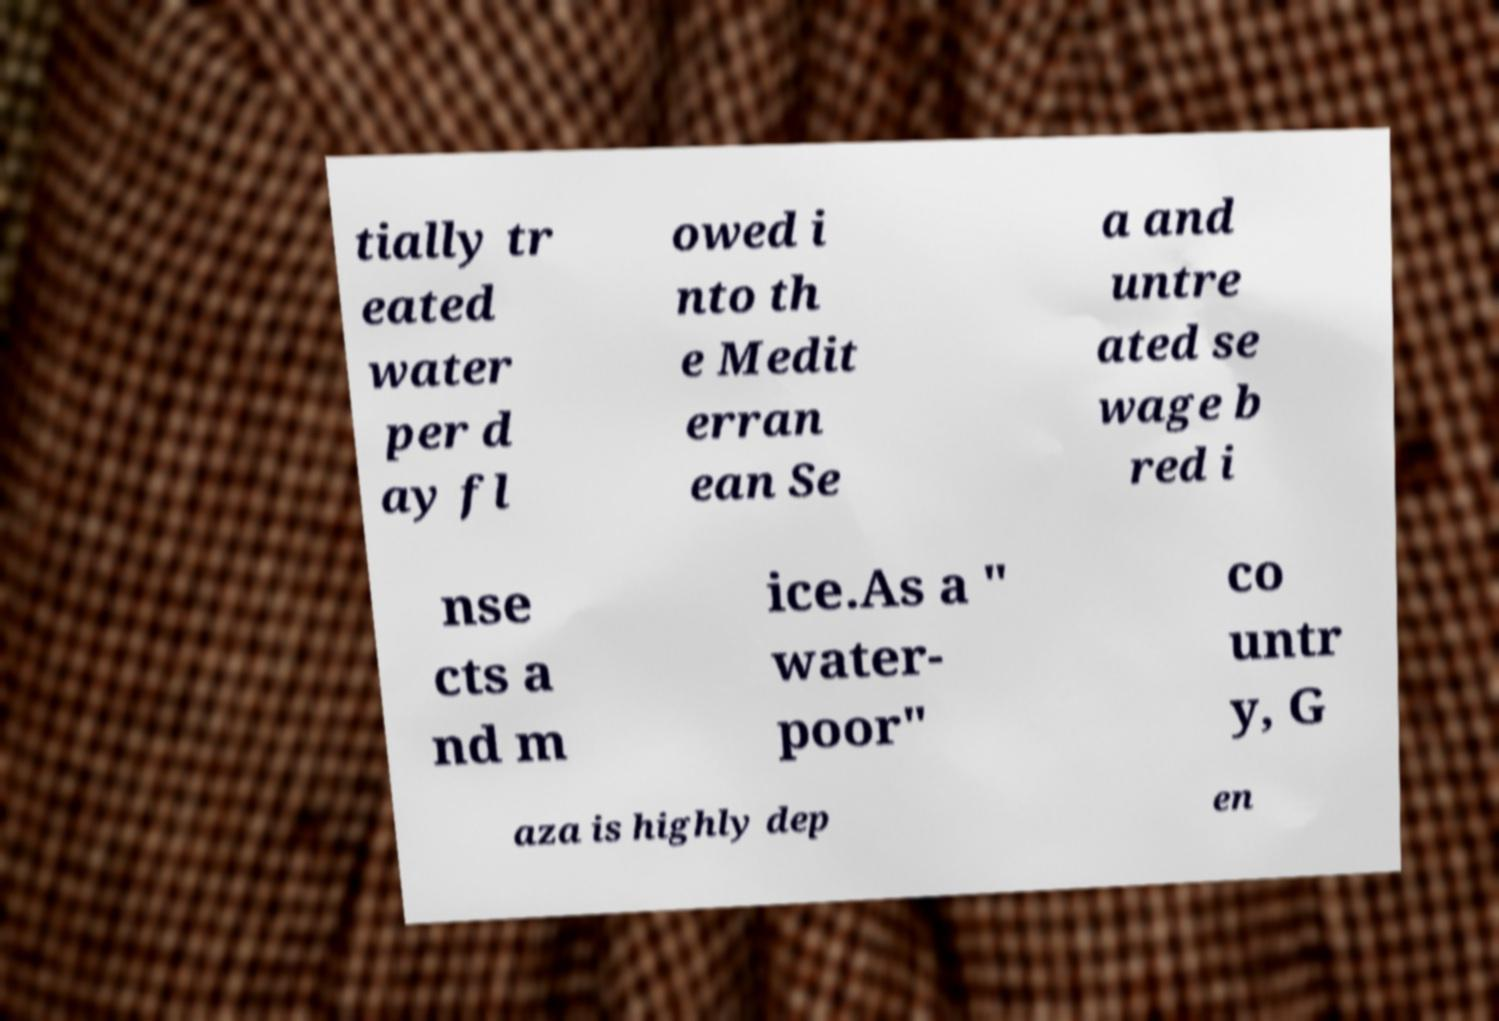Please read and relay the text visible in this image. What does it say? tially tr eated water per d ay fl owed i nto th e Medit erran ean Se a and untre ated se wage b red i nse cts a nd m ice.As a " water- poor" co untr y, G aza is highly dep en 